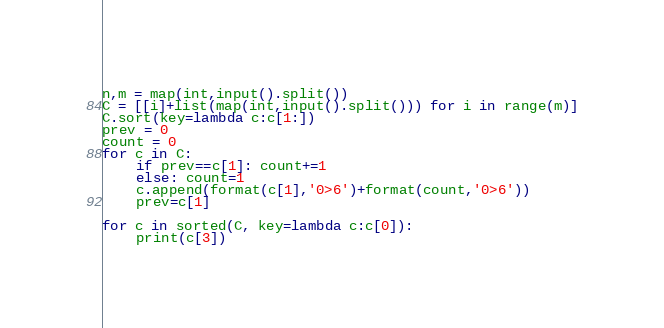<code> <loc_0><loc_0><loc_500><loc_500><_Python_>n,m = map(int,input().split())
C = [[i]+list(map(int,input().split())) for i in range(m)]
C.sort(key=lambda c:c[1:])
prev = 0
count = 0
for c in C:
    if prev==c[1]: count+=1
    else: count=1
    c.append(format(c[1],'0>6')+format(count,'0>6'))
    prev=c[1]

for c in sorted(C, key=lambda c:c[0]):
    print(c[3])</code> 